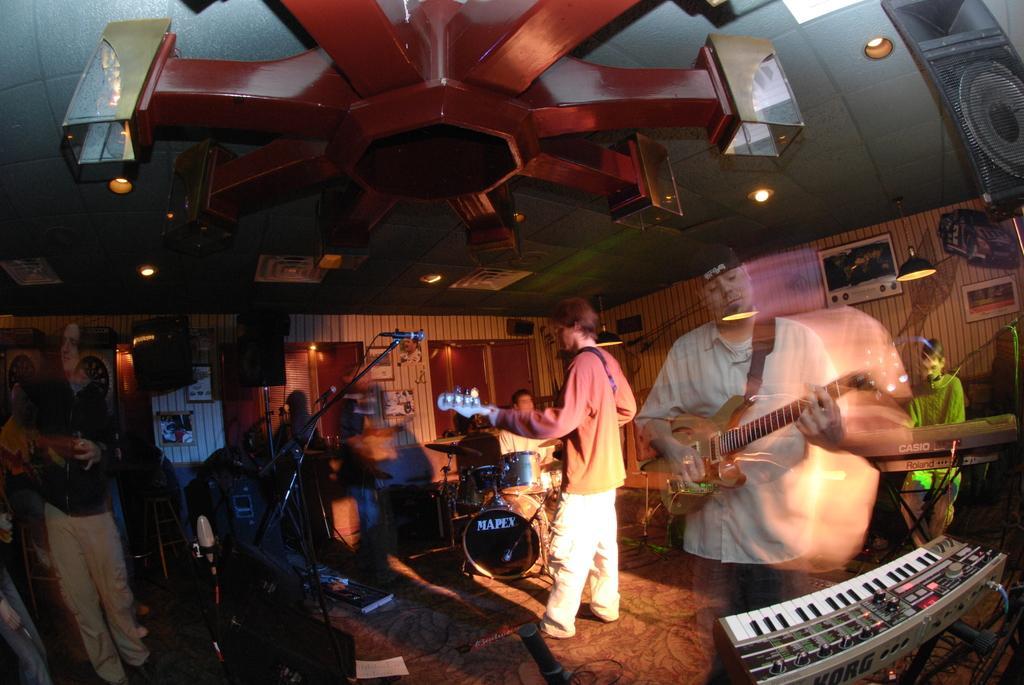How would you summarize this image in a sentence or two? This image is taken inside a room. At the top of the image there is a ceiling with lights. At the bottom of the image there is a floor with mat, there are few people in this room playing a musical instruments. At the background there is a wall with windows and doors. 